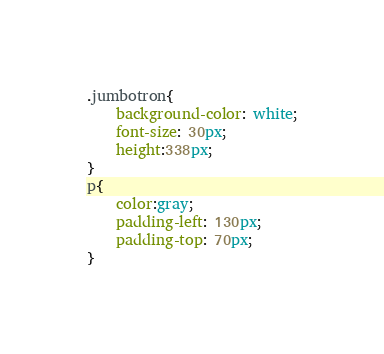<code> <loc_0><loc_0><loc_500><loc_500><_CSS_>.jumbotron{
    background-color: white;
    font-size: 30px;
    height:338px;
}
p{
    color:gray;
    padding-left: 130px;
    padding-top: 70px;
}</code> 